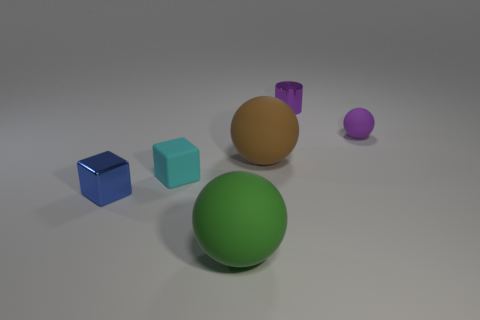Subtract all red spheres. Subtract all purple cylinders. How many spheres are left? 3 Add 1 blue metallic blocks. How many objects exist? 7 Subtract all cylinders. How many objects are left? 5 Subtract 0 cyan spheres. How many objects are left? 6 Subtract all small brown metallic cylinders. Subtract all large green matte objects. How many objects are left? 5 Add 3 metal objects. How many metal objects are left? 5 Add 2 big yellow rubber spheres. How many big yellow rubber spheres exist? 2 